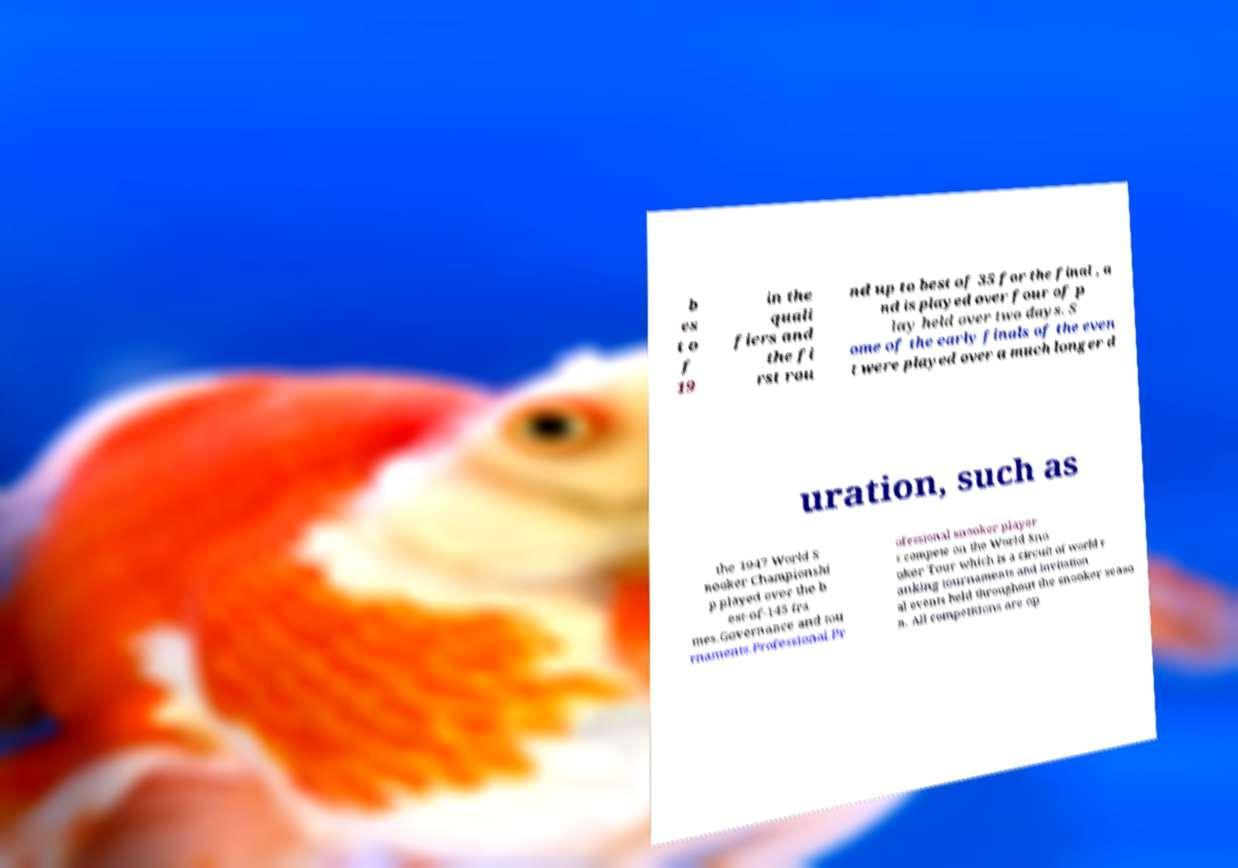What messages or text are displayed in this image? I need them in a readable, typed format. b es t o f 19 in the quali fiers and the fi rst rou nd up to best of 35 for the final , a nd is played over four of p lay held over two days. S ome of the early finals of the even t were played over a much longer d uration, such as the 1947 World S nooker Championshi p played over the b est-of-145 fra mes.Governance and tou rnaments.Professional.Pr ofessional snooker player s compete on the World Sno oker Tour which is a circuit of world r anking tournaments and invitation al events held throughout the snooker seaso n. All competitions are op 